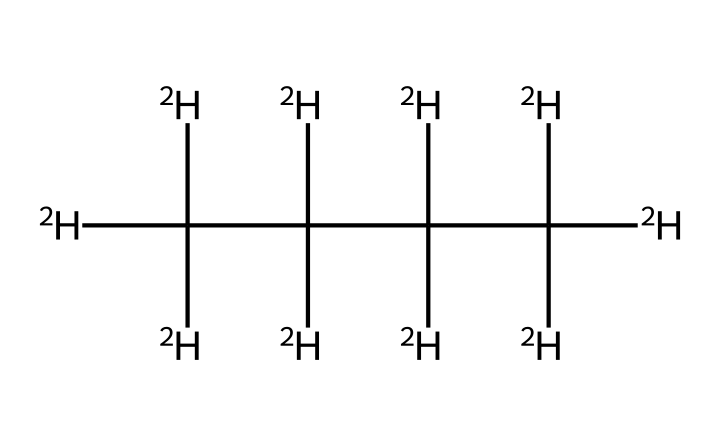What is the main isotopic variant present in the chemical structure? The chemical structure indicates the presence of deuterium, denoted by [2H], which is an isotope of hydrogen.
Answer: deuterium How many carbon atoms are in the structure? In the SMILES representation, each capital "C" stands for a carbon atom. There are six "C" atoms present in the structure.
Answer: six What is the total number of hydrogen atoms associated with this structure? Each carbon in the structure is connected to either deuterium or hydrogens. There are a total of twelve deuterium atoms indicated by [2H] in the structure.
Answer: twelve What type of polymer is represented by this structure? The structure of deuterated polyethylene indicates that it is a type of polymer formed from repeating units of ethylene with deuterium substitutions.
Answer: polyethylene How does deuterated polyethylene differ from regular polyethylene in terms of isotopes? Deuterated polyethylene has deuterium atoms instead of regular hydrogen, which alters the properties, such as thermal stability and reaction rates, enabling unique performance characteristics in parts.
Answer: deuterium substitution 